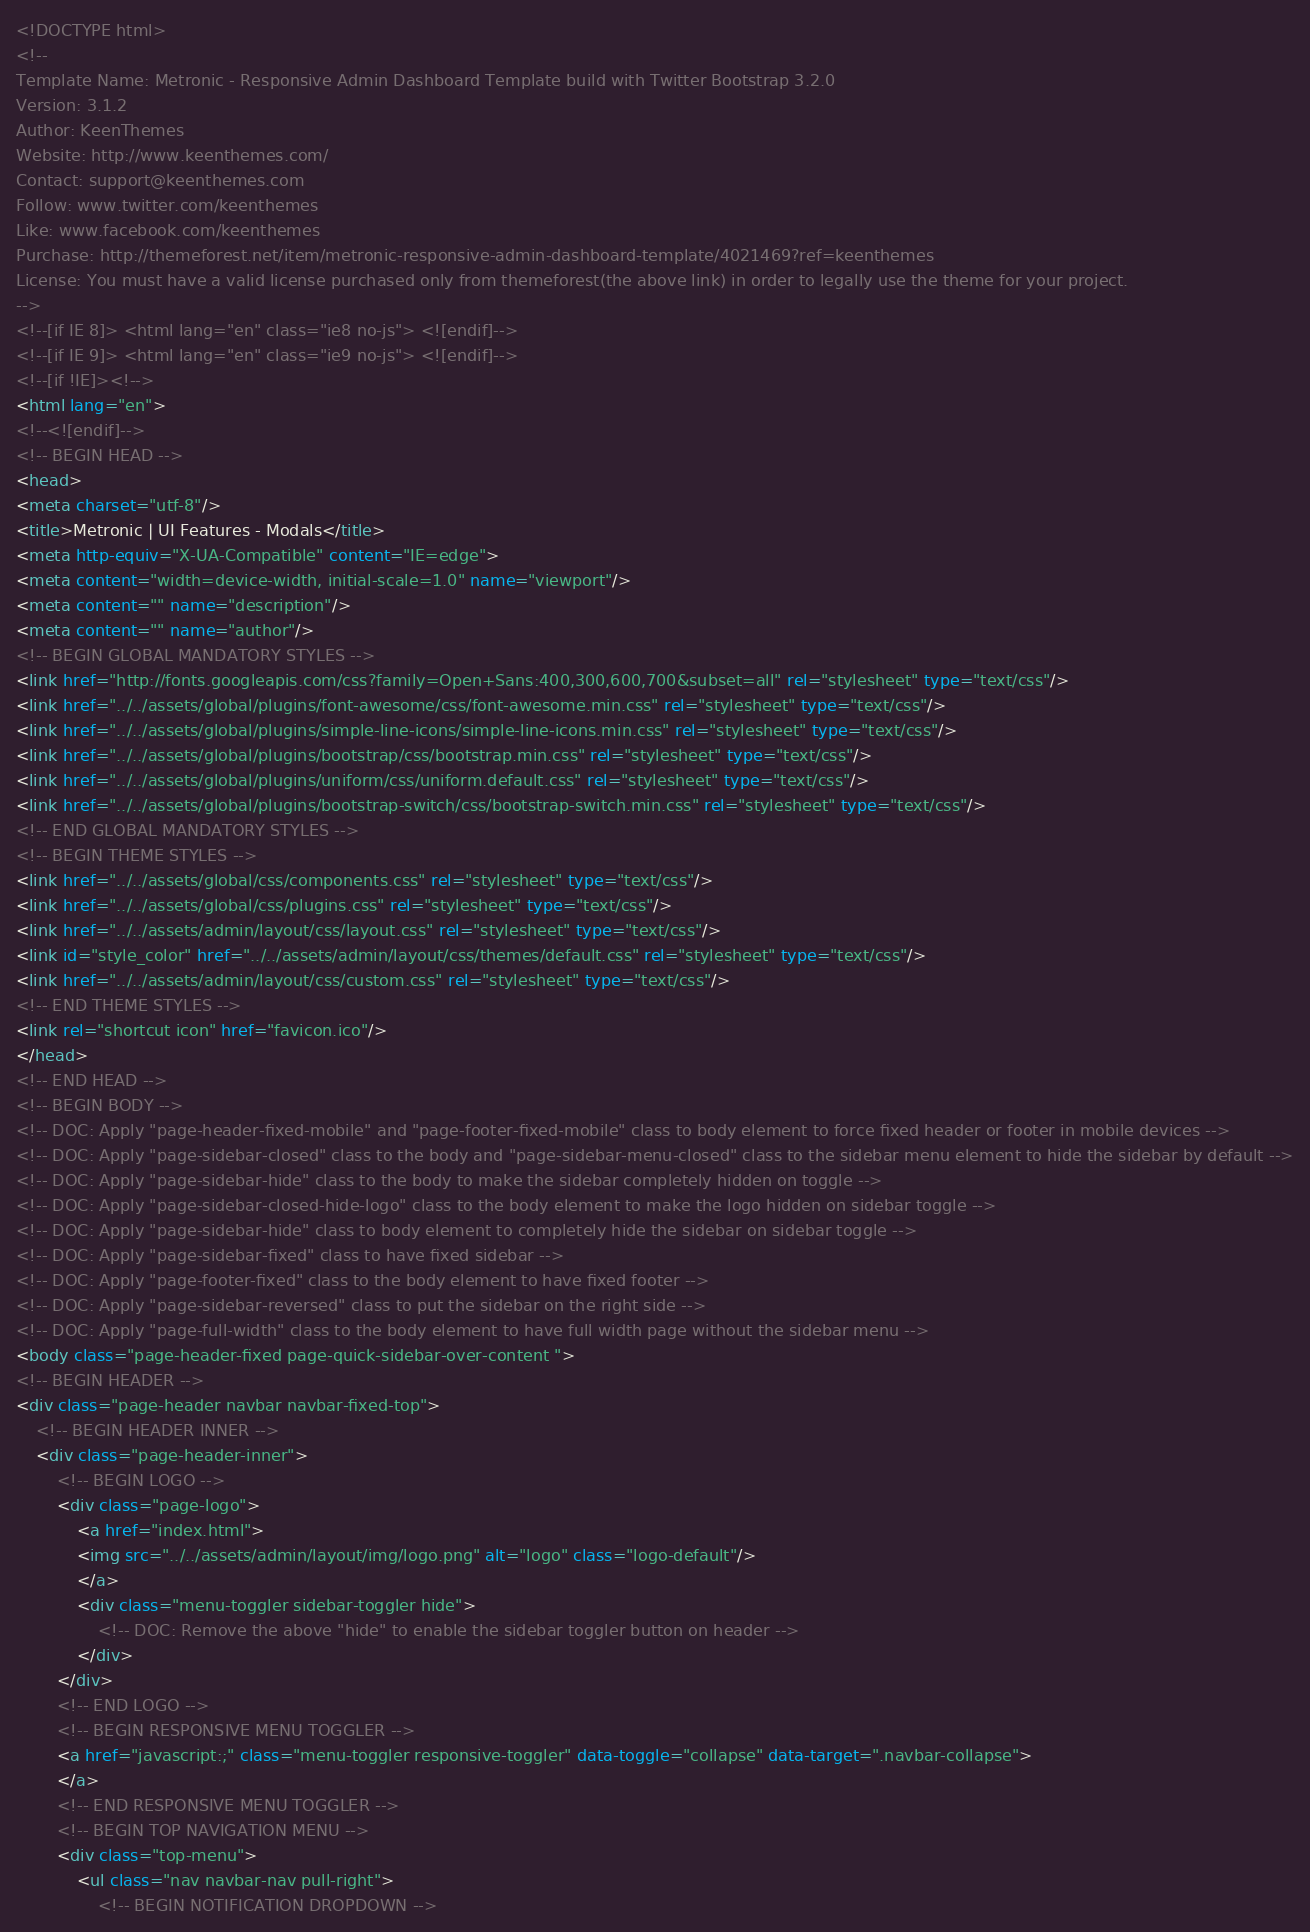Convert code to text. <code><loc_0><loc_0><loc_500><loc_500><_HTML_><!DOCTYPE html>
<!-- 
Template Name: Metronic - Responsive Admin Dashboard Template build with Twitter Bootstrap 3.2.0
Version: 3.1.2
Author: KeenThemes
Website: http://www.keenthemes.com/
Contact: support@keenthemes.com
Follow: www.twitter.com/keenthemes
Like: www.facebook.com/keenthemes
Purchase: http://themeforest.net/item/metronic-responsive-admin-dashboard-template/4021469?ref=keenthemes
License: You must have a valid license purchased only from themeforest(the above link) in order to legally use the theme for your project.
-->
<!--[if IE 8]> <html lang="en" class="ie8 no-js"> <![endif]-->
<!--[if IE 9]> <html lang="en" class="ie9 no-js"> <![endif]-->
<!--[if !IE]><!-->
<html lang="en">
<!--<![endif]-->
<!-- BEGIN HEAD -->
<head>
<meta charset="utf-8"/>
<title>Metronic | UI Features - Modals</title>
<meta http-equiv="X-UA-Compatible" content="IE=edge">
<meta content="width=device-width, initial-scale=1.0" name="viewport"/>
<meta content="" name="description"/>
<meta content="" name="author"/>
<!-- BEGIN GLOBAL MANDATORY STYLES -->
<link href="http://fonts.googleapis.com/css?family=Open+Sans:400,300,600,700&subset=all" rel="stylesheet" type="text/css"/>
<link href="../../assets/global/plugins/font-awesome/css/font-awesome.min.css" rel="stylesheet" type="text/css"/>
<link href="../../assets/global/plugins/simple-line-icons/simple-line-icons.min.css" rel="stylesheet" type="text/css"/>
<link href="../../assets/global/plugins/bootstrap/css/bootstrap.min.css" rel="stylesheet" type="text/css"/>
<link href="../../assets/global/plugins/uniform/css/uniform.default.css" rel="stylesheet" type="text/css"/>
<link href="../../assets/global/plugins/bootstrap-switch/css/bootstrap-switch.min.css" rel="stylesheet" type="text/css"/>
<!-- END GLOBAL MANDATORY STYLES -->
<!-- BEGIN THEME STYLES -->
<link href="../../assets/global/css/components.css" rel="stylesheet" type="text/css"/>
<link href="../../assets/global/css/plugins.css" rel="stylesheet" type="text/css"/>
<link href="../../assets/admin/layout/css/layout.css" rel="stylesheet" type="text/css"/>
<link id="style_color" href="../../assets/admin/layout/css/themes/default.css" rel="stylesheet" type="text/css"/>
<link href="../../assets/admin/layout/css/custom.css" rel="stylesheet" type="text/css"/>
<!-- END THEME STYLES -->
<link rel="shortcut icon" href="favicon.ico"/>
</head>
<!-- END HEAD -->
<!-- BEGIN BODY -->
<!-- DOC: Apply "page-header-fixed-mobile" and "page-footer-fixed-mobile" class to body element to force fixed header or footer in mobile devices -->
<!-- DOC: Apply "page-sidebar-closed" class to the body and "page-sidebar-menu-closed" class to the sidebar menu element to hide the sidebar by default -->
<!-- DOC: Apply "page-sidebar-hide" class to the body to make the sidebar completely hidden on toggle -->
<!-- DOC: Apply "page-sidebar-closed-hide-logo" class to the body element to make the logo hidden on sidebar toggle -->
<!-- DOC: Apply "page-sidebar-hide" class to body element to completely hide the sidebar on sidebar toggle -->
<!-- DOC: Apply "page-sidebar-fixed" class to have fixed sidebar -->
<!-- DOC: Apply "page-footer-fixed" class to the body element to have fixed footer -->
<!-- DOC: Apply "page-sidebar-reversed" class to put the sidebar on the right side -->
<!-- DOC: Apply "page-full-width" class to the body element to have full width page without the sidebar menu -->
<body class="page-header-fixed page-quick-sidebar-over-content ">
<!-- BEGIN HEADER -->
<div class="page-header navbar navbar-fixed-top">
	<!-- BEGIN HEADER INNER -->
	<div class="page-header-inner">
		<!-- BEGIN LOGO -->
		<div class="page-logo">
			<a href="index.html">
			<img src="../../assets/admin/layout/img/logo.png" alt="logo" class="logo-default"/>
			</a>
			<div class="menu-toggler sidebar-toggler hide">
				<!-- DOC: Remove the above "hide" to enable the sidebar toggler button on header -->
			</div>
		</div>
		<!-- END LOGO -->
		<!-- BEGIN RESPONSIVE MENU TOGGLER -->
		<a href="javascript:;" class="menu-toggler responsive-toggler" data-toggle="collapse" data-target=".navbar-collapse">
		</a>
		<!-- END RESPONSIVE MENU TOGGLER -->
		<!-- BEGIN TOP NAVIGATION MENU -->
		<div class="top-menu">
			<ul class="nav navbar-nav pull-right">
				<!-- BEGIN NOTIFICATION DROPDOWN --></code> 